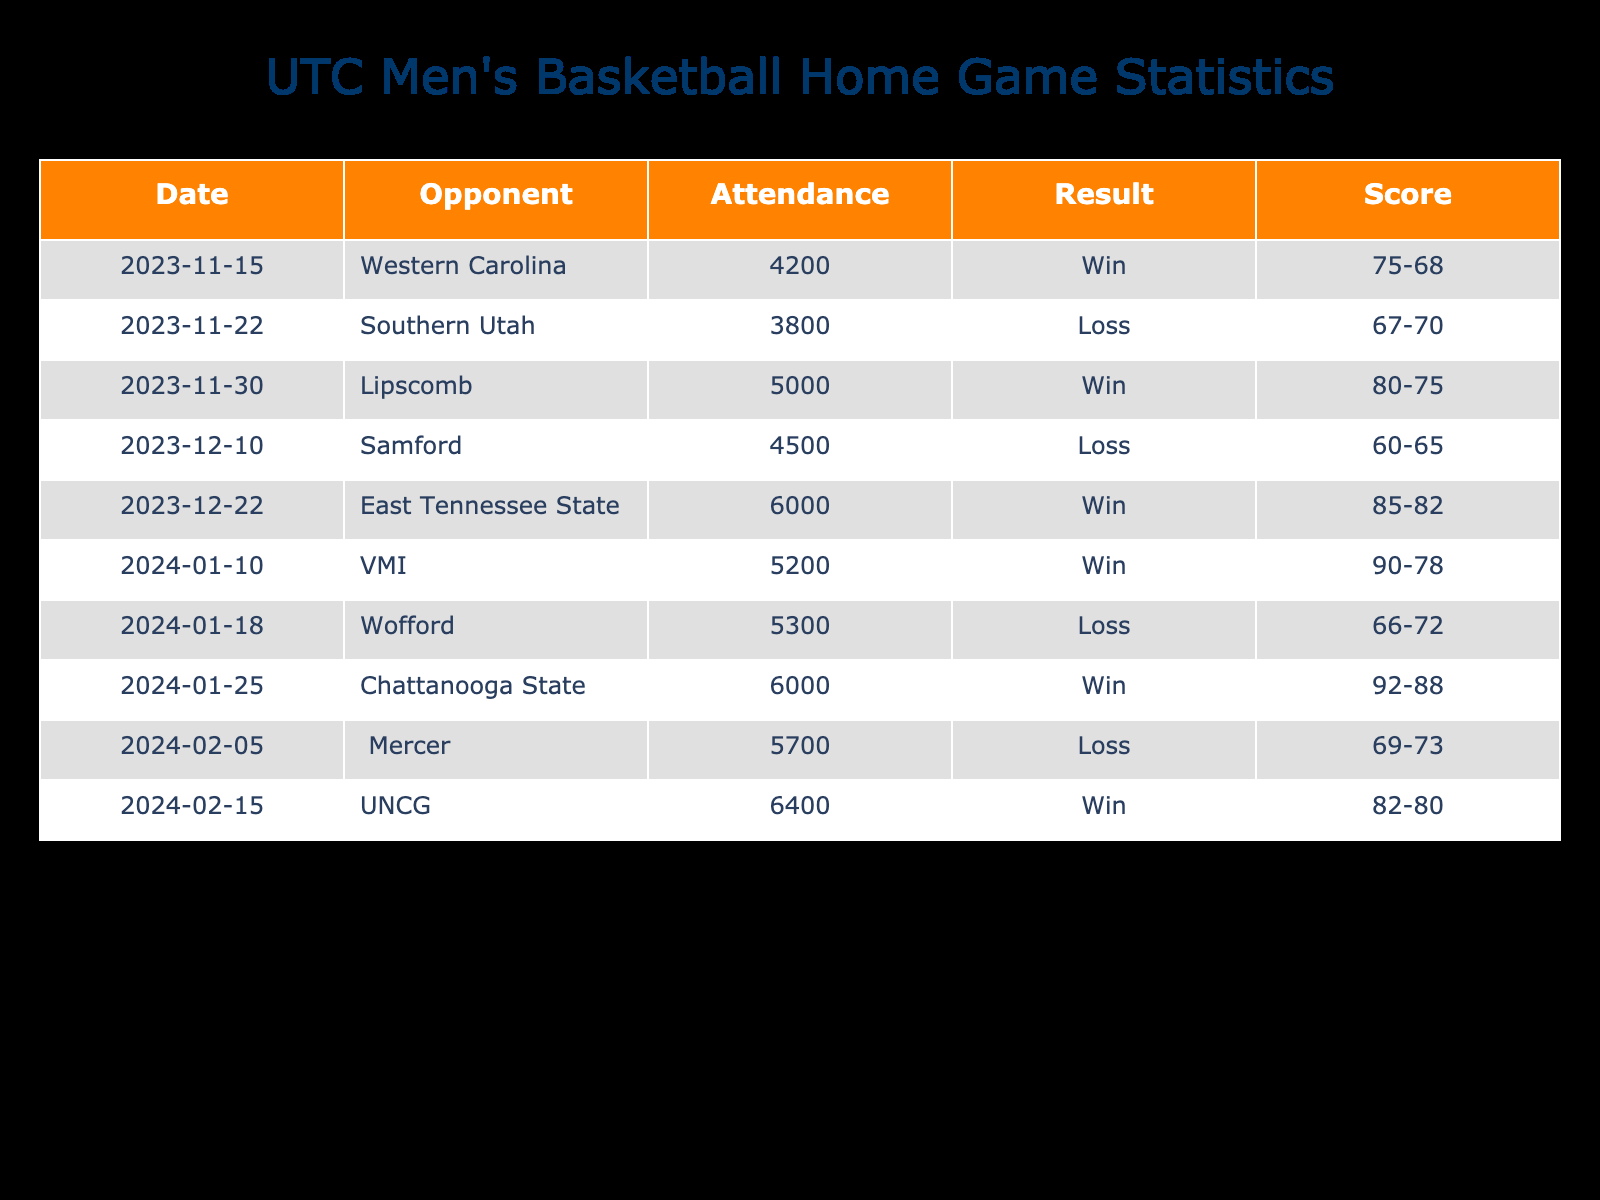What was the highest attendance for a home game? The attendance numbers for each game are listed in the "Attendance" column. The highest number is 6400, which occurred during the UNCG game on February 15, 2024.
Answer: 6400 What was the record of wins and losses by the 2023-2024 season? The results for each game are shown in the "Result" column. There are 5 wins (W) and 4 losses (L) based on the data provided.
Answer: 5 wins, 4 losses What was the average attendance across all games? To calculate the average, add all attendance values: 4200 + 3800 + 5000 + 4500 + 6000 + 5200 + 5300 + 6000 + 5700 + 6400 =  5,520. Then, divide by the number of games (10): 55200 / 10 = 5520.
Answer: 5520 Did UTC score more points than they allowed in the game against East Tennessee State? In the row for the East Tennessee State game, the points scored were 85 and the points allowed were 82. Since 85 is greater than 82, they did score more points than allowed.
Answer: Yes How many games did UTC win in which the attendance was over 5000? From the table, the games with attendance greater than 5000 are listed, and the wins in those games can be identified. The games against Lipscomb (5000), Chattanooga State (6000), East Tennessee State (6000), and UNCG (6400) had attendances over 5000, with four wins (Lipscomb, Chattanooga State, East Tennessee State, UNCG).
Answer: 3 games What is the difference between points scored and points allowed in the match against VMI? The points scored are 90 and the points allowed are 78. The difference is calculated by subtracting the points allowed from the points scored: 90 - 78 = 12.
Answer: 12 What was the average score registered in losses? First, identify the losses from the "Result" column: Southern Utah (67-70), Samford (60-65), Wofford (66-72), and Mercer (69-73). The total points scored in those losses: (67 + 60 + 66 + 69) = 262 across 4 games, so the average is 262 / 4 = 65.5.
Answer: 65.5 Was there any loss where the attendance was above 6000? Looking through the table, the losses against Southern Utah (3800), Samford (4500), Wofford (5300), and Mercer (5700) indicate that none of those had an attendance figure above 6000.
Answer: No How many total points did UTC score at home in all the games listed? The points scored in each game are summed: 75 + 67 + 80 + 60 + 85 + 90 + 66 + 92 + 69 + 82 =  796.
Answer: 796 